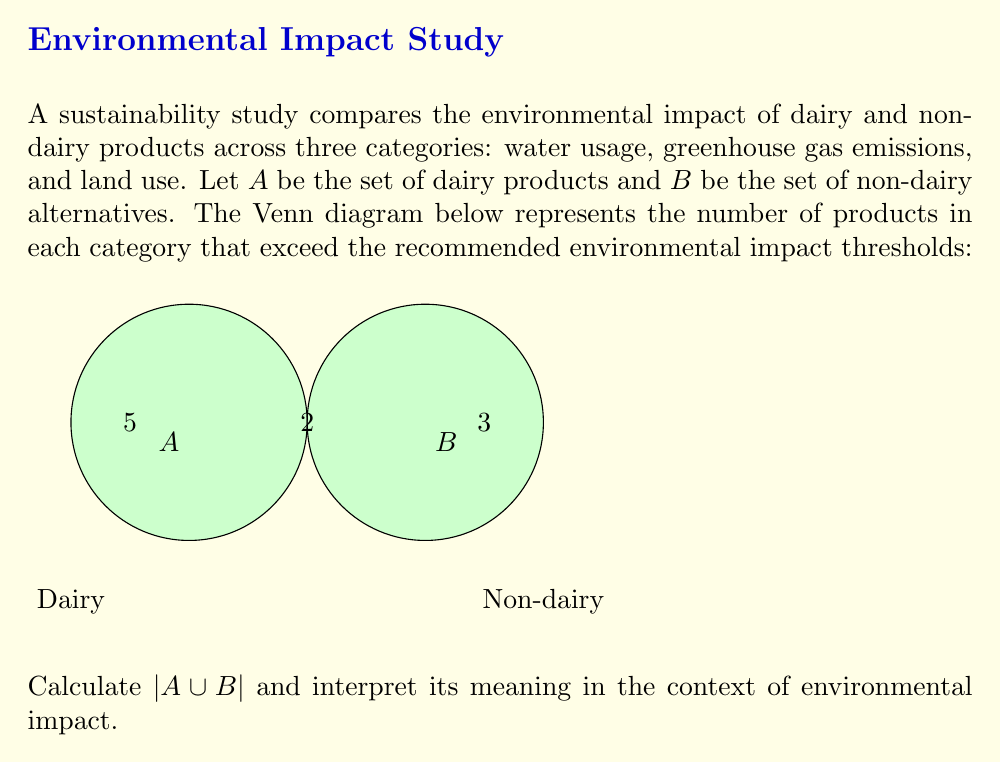Could you help me with this problem? To solve this problem, we'll use the set theory formula for the union of two sets:

$$|A \cup B| = |A| + |B| - |A \cap B|$$

Step 1: Identify the values from the Venn diagram:
- $|A| = 5 + 2 = 7$ (total number of dairy products exceeding thresholds)
- $|B| = 3 + 2 = 5$ (total number of non-dairy products exceeding thresholds)
- $|A \cap B| = 2$ (number of products in both sets exceeding thresholds)

Step 2: Apply the formula:
$$|A \cup B| = 7 + 5 - 2 = 10$$

Step 3: Interpret the result:
$|A \cup B| = 10$ represents the total number of unique products (both dairy and non-dairy) that exceed the recommended environmental impact thresholds in at least one category (water usage, greenhouse gas emissions, or land use).

This result suggests that out of all the products studied, 10 distinct products have a significant environmental impact, regardless of whether they are dairy or non-dairy. This information is crucial for a sustainability advocate, as it highlights that both dairy and non-dairy products can have environmental concerns, and careful consideration is needed when choosing alternatives.
Answer: $|A \cup B| = 10$, representing the total number of unique products exceeding environmental impact thresholds. 